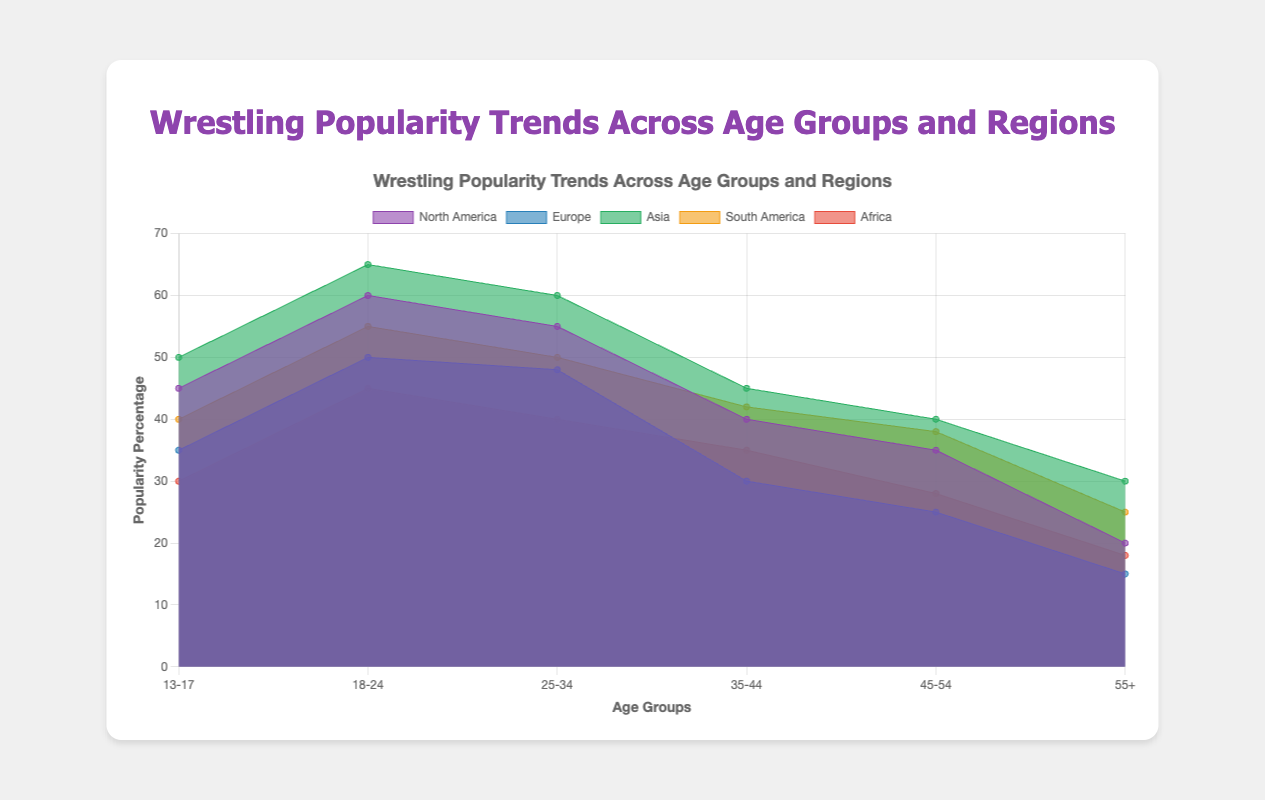What age group has the highest popularity percentage in North America? The highest popularity percentage in North America is found in the age group 18-24 with a percentage of 60.
Answer: 18-24 Which region shows the highest popularity among the 25-34 age group? The region with the highest popularity percentage for the 25-34 age group is Asia with a percentage of 60.
Answer: Asia Compare the popularity percentages for the 55+ age group across all regions. Which region has the lowest percentage? Examining the 55+ age group reveals that Europe has the lowest popularity percentage at 15.
Answer: Europe What's the average popularity percentage for the age group 35-44 in South America and Africa? The percentages are 42 for South America and 35 for Africa. The average is calculated by (42 + 35) / 2 = 38.5.
Answer: 38.5 Which age group in Asia has a popularity percentage higher than 60? In Asia, the age group 18-24 has a popularity percentage of 65, which is higher than 60.
Answer: 18-24 Is the trend of popularity percentages generally increasing or decreasing with age across all regions? Generally, the trend shows a decrease in popularity percentages with increasing age across all regions.
Answer: Decreasing Among the age groups 45-54, which two regions have the biggest difference in popularity percentages and what is the difference? Comparing the percentages: North America (35), Europe (25), Asia (40), South America (38), Africa (28). The biggest difference is between Asia (40) and Europe (25), which amounts to 15.
Answer: 15 For the 18-24 age group, order the regions from highest to lowest popularity percentage. The percentages are as follows: Asia (65), North America (60), South America (55), Europe (50), Africa (45). Thus, Asia > North America > South America > Europe > Africa.
Answer: Asia, North America, South America, Europe, Africa How does the popularity of wrestling in the age group 13-17 in North America compare to Europe? The 13-17 age group in North America has a popularity percentage of 45, while in Europe it is 35. North America has a higher percentage by 10.
Answer: North America by 10 